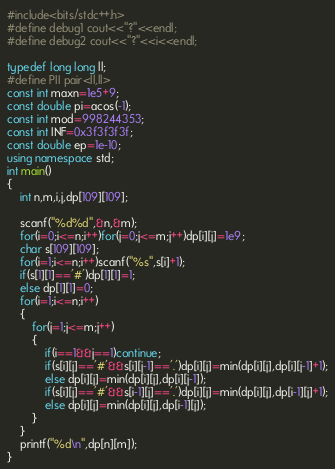Convert code to text. <code><loc_0><loc_0><loc_500><loc_500><_C++_>#include<bits/stdc++.h>
#define debug1 cout<<"?"<<endl;
#define debug2 cout<<"?"<<i<<endl;

typedef long long ll;
#define PII pair<ll,ll>
const int maxn=1e5+9;
const double pi=acos(-1);
const int mod=998244353;
const int INF=0x3f3f3f3f;
const double ep=1e-10;
using namespace std;
int main()
{
	int n,m,i,j,dp[109][109];
	
	scanf("%d%d",&n,&m);
	for(i=0;i<=n;i++)for(j=0;j<=m;j++)dp[i][j]=1e9;
	char s[109][109];
	for(i=1;i<=n;i++)scanf("%s",s[i]+1);
	if(s[1][1]=='#')dp[1][1]=1;
	else dp[1][1]=0;
	for(i=1;i<=n;i++)
	{
		for(j=1;j<=m;j++)
		{
			if(i==1&&j==1)continue;
			if(s[i][j]=='#'&&s[i][j-1]=='.')dp[i][j]=min(dp[i][j],dp[i][j-1]+1);
			else dp[i][j]=min(dp[i][j],dp[i][j-1]);
			if(s[i][j]=='#'&&s[i-1][j]=='.')dp[i][j]=min(dp[i][j],dp[i-1][j]+1);
			else dp[i][j]=min(dp[i][j],dp[i-1][j]);
		}
	}
	printf("%d\n",dp[n][m]);
}</code> 